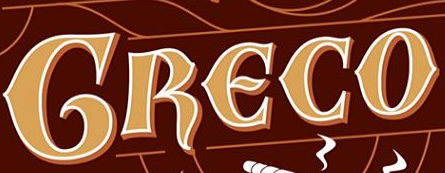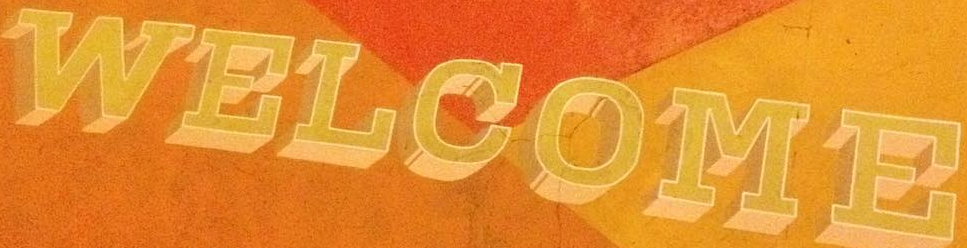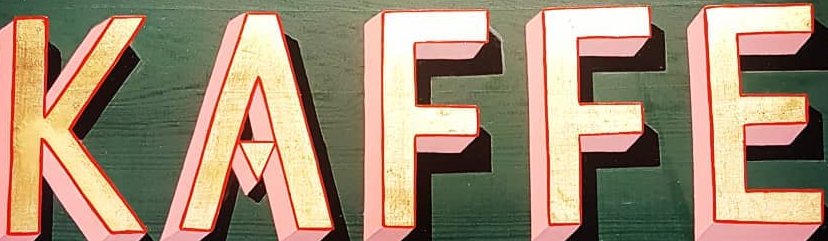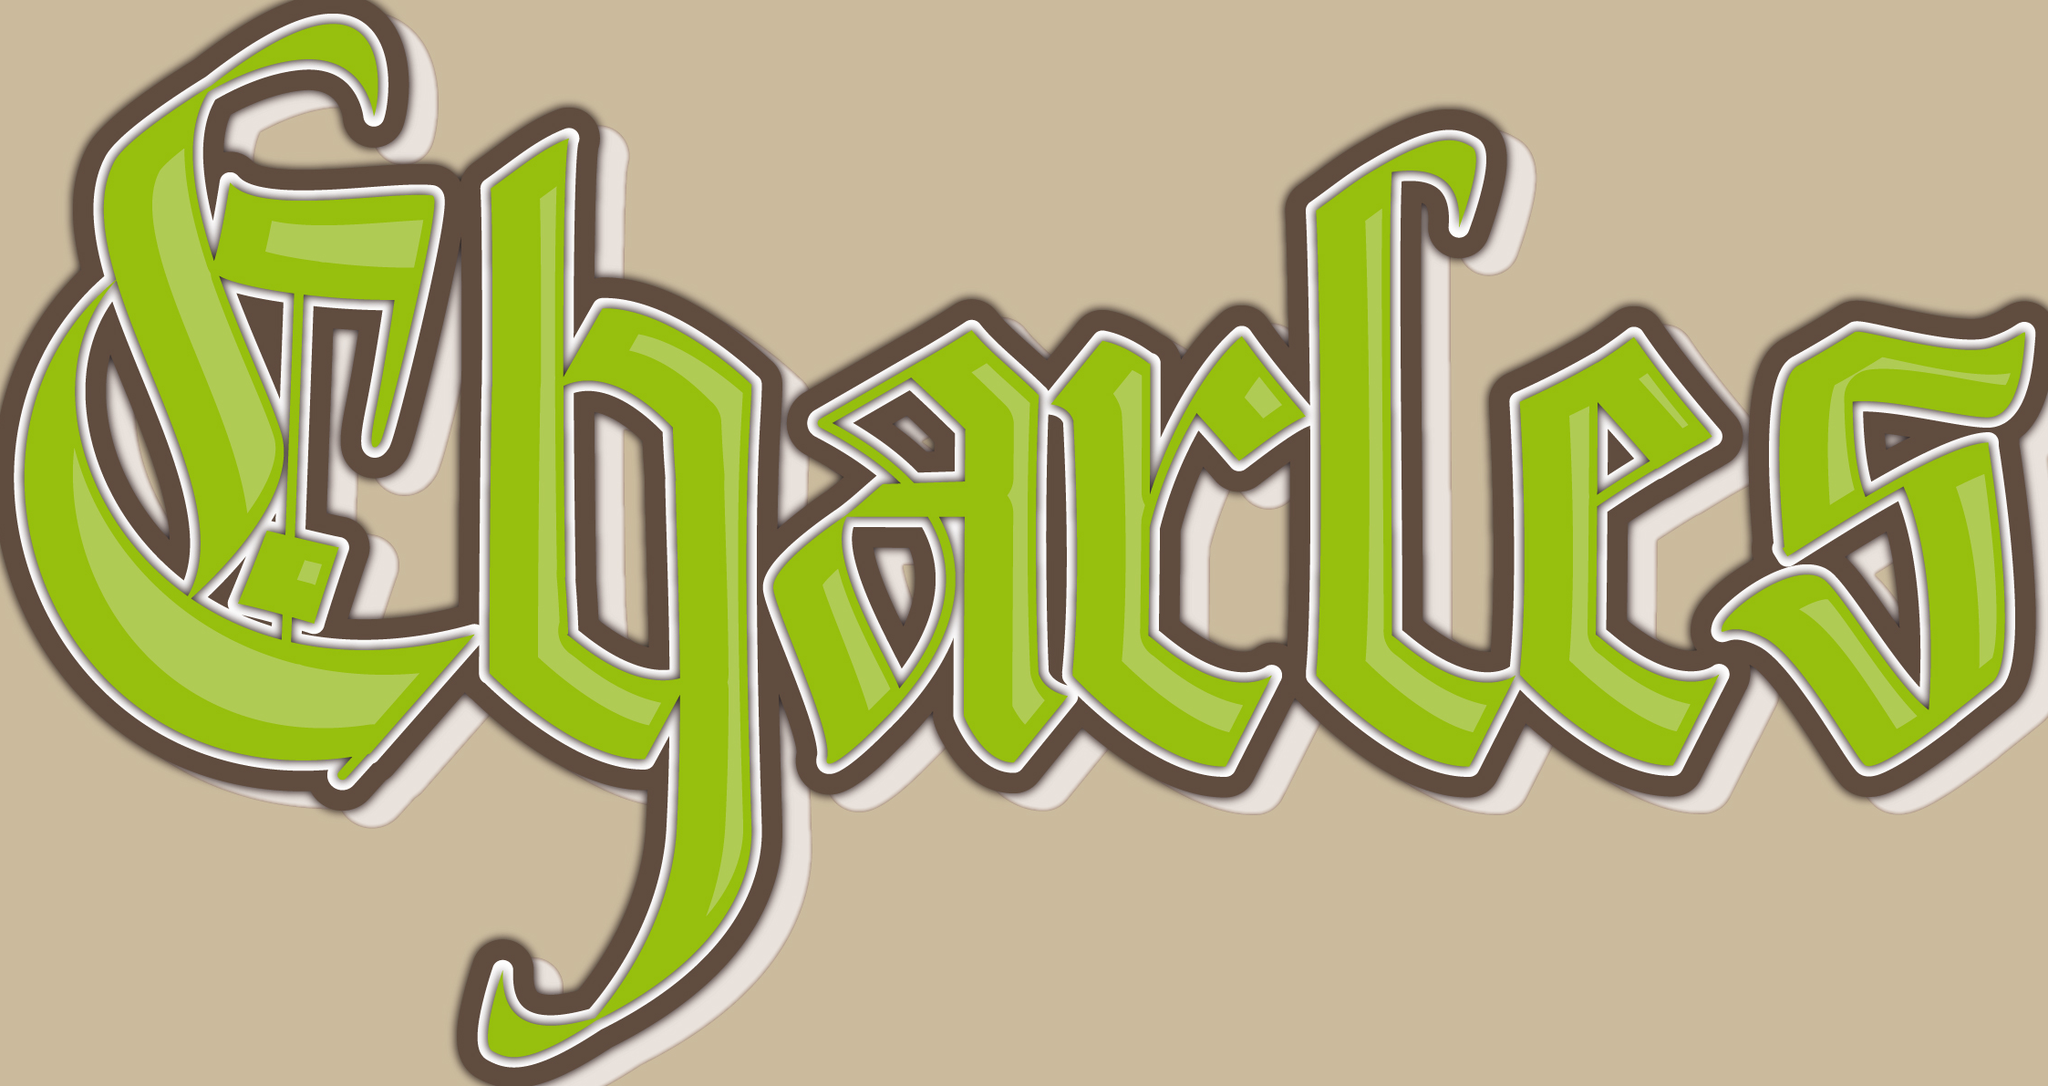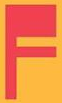Read the text from these images in sequence, separated by a semicolon. GRECO; WELCOME; KAFFE; Charles; F 